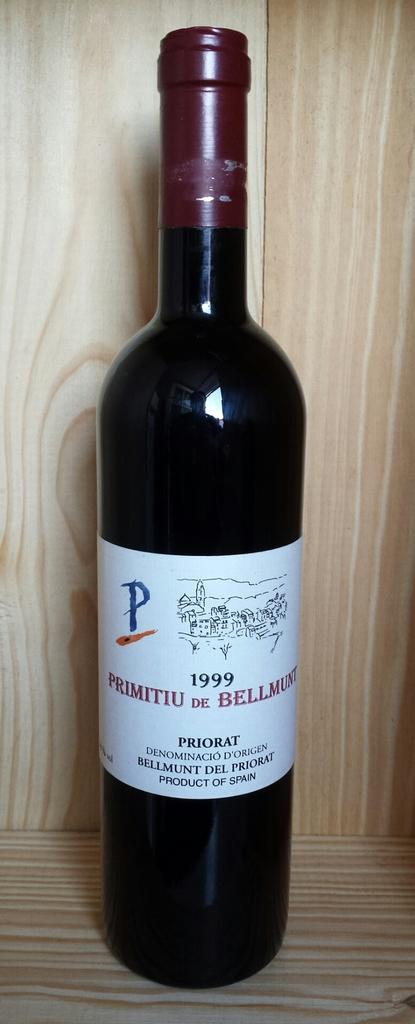<image>
Present a compact description of the photo's key features. A bottle of 1999 Primitiu DeBellmunt from Spain is in a wooden cabinet. 